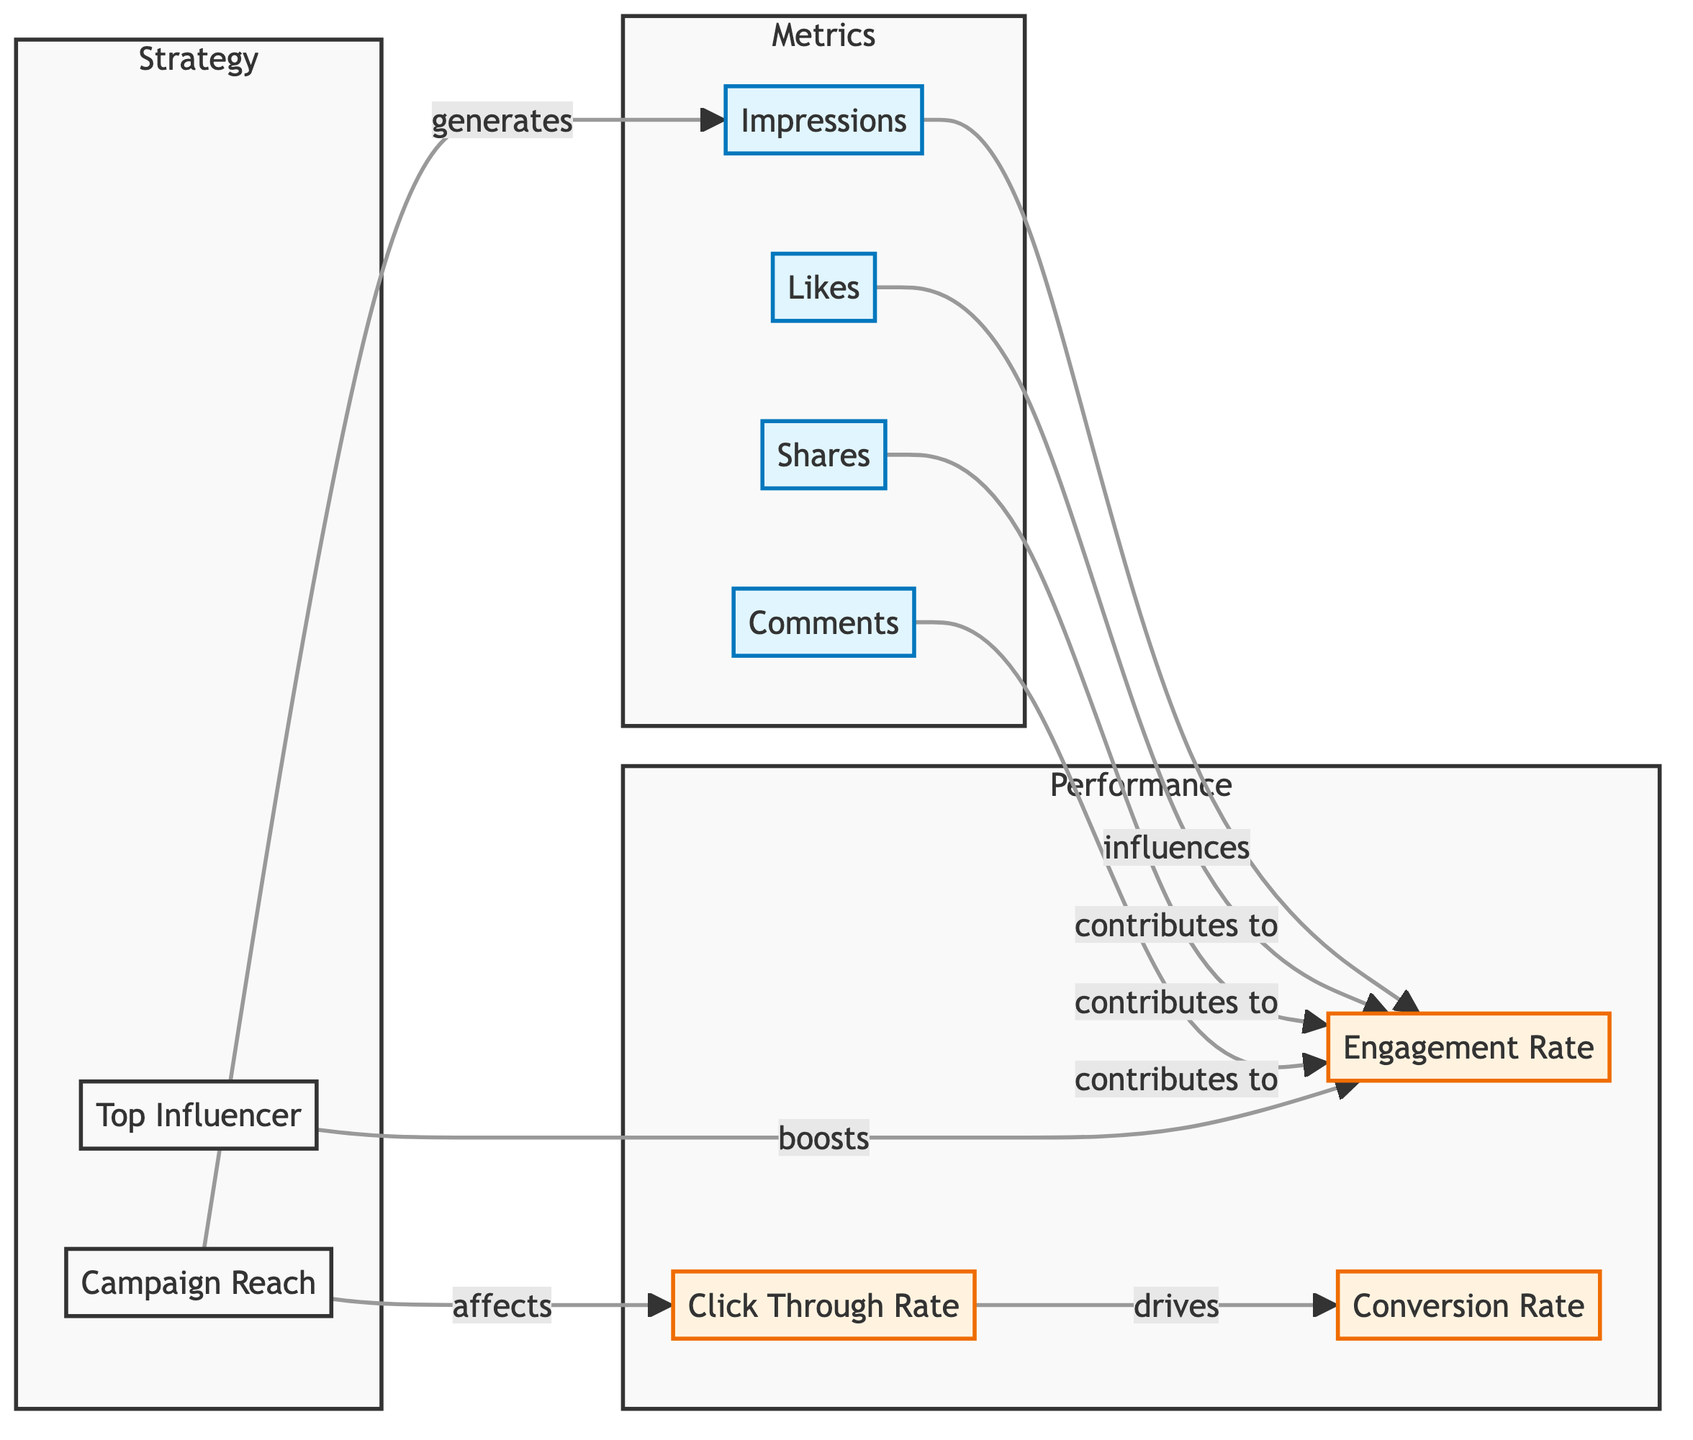What are the four main metrics listed in the diagram? The diagram clearly lists four main metrics: Impressions, Likes, Shares, and Comments. These are categorized within the "Metrics" subgraph.
Answer: Impressions, Likes, Shares, Comments What relationship exists between Campaign Reach and Impressions? The arrow in the diagram indicates that Campaign Reach generates Impressions, showing a direct influence from Campaign Reach on the number of Impressions.
Answer: generates How many metrics are there in total in the diagram? Counting the nodes under the "Metrics" subgraph gives us four metrics, and there are three metrics under the "Performance" subgraph, yielding a total of seven metrics.
Answer: seven What contributes to the Engagement Rate? The diagram indicates that Likes, Shares, Comments, and Impressions all contribute to the Engagement Rate, as shown by the arrows pointing to Engagement Rate from these metrics.
Answer: Likes, Shares, Comments, Impressions What does Click Through Rate influence according to the diagram? The arrow illustrates that the Click Through Rate drives Conversion Rate, establishing a directional influence from Click Through Rate to Conversion Rate.
Answer: drives Which element boosts the Engagement Rate? The diagram indicates that the Top Influencer boosts the Engagement Rate, as shown by the arrow connecting the two elements.
Answer: boosts What is the overall structure of the diagram divided into? The structure of the diagram is divided into three main subgraphs: Metrics, Performance, and Strategy, each containing different related components.
Answer: three How does Engagement Rate relate to Impressions? The diagram displays an arrow from Impressions to Engagement Rate, indicating that Impressions influence Engagement Rate, establishing a direct relationship.
Answer: influences What is a direct output of the Click Through Rate? As per the diagram, the direct output of Click Through Rate is Conversion Rate, shown by the connecting arrow that points towards Conversion Rate.
Answer: Conversion Rate 